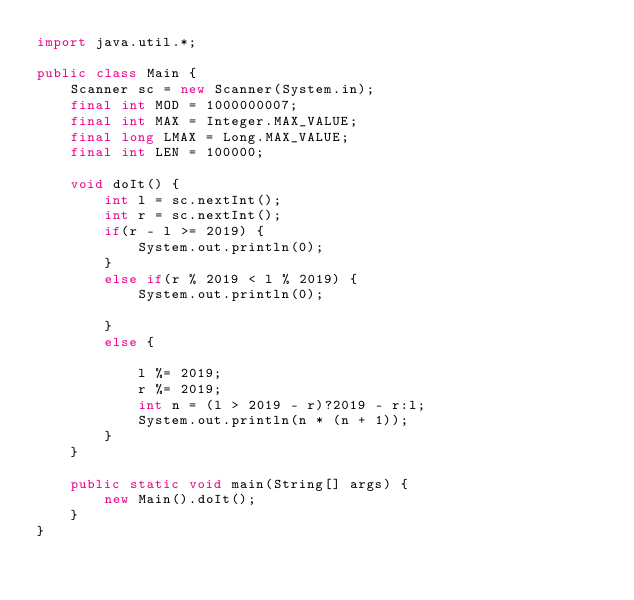Convert code to text. <code><loc_0><loc_0><loc_500><loc_500><_Java_>import java.util.*;

public class Main {
	Scanner sc = new Scanner(System.in);
	final int MOD = 1000000007;
	final int MAX = Integer.MAX_VALUE;
	final long LMAX = Long.MAX_VALUE;
	final int LEN = 100000;

	void doIt() {
		int l = sc.nextInt();
		int r = sc.nextInt();
		if(r - l >= 2019) {
			System.out.println(0);
		}
		else if(r % 2019 < l % 2019) {
			System.out.println(0);
			
		}
		else {
			
			l %= 2019;
			r %= 2019;
			int n = (l > 2019 - r)?2019 - r:l;
			System.out.println(n * (n + 1));
		}
	}
	
	public static void main(String[] args) {
		new Main().doIt();
	}
}
</code> 